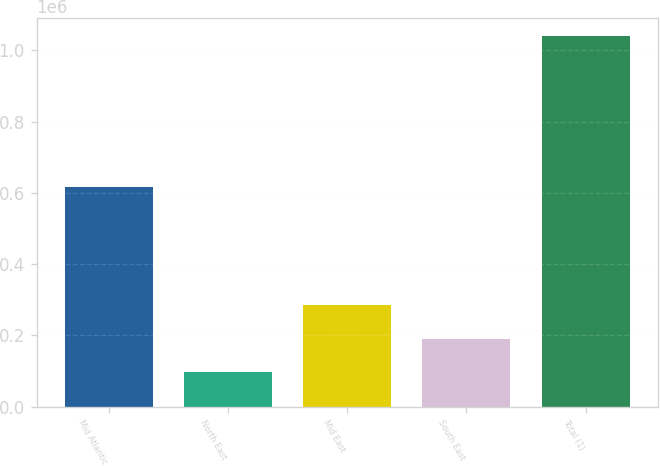Convert chart to OTSL. <chart><loc_0><loc_0><loc_500><loc_500><bar_chart><fcel>Mid Atlantic<fcel>North East<fcel>Mid East<fcel>South East<fcel>Total (1)<nl><fcel>617471<fcel>96412<fcel>284864<fcel>190638<fcel>1.03867e+06<nl></chart> 